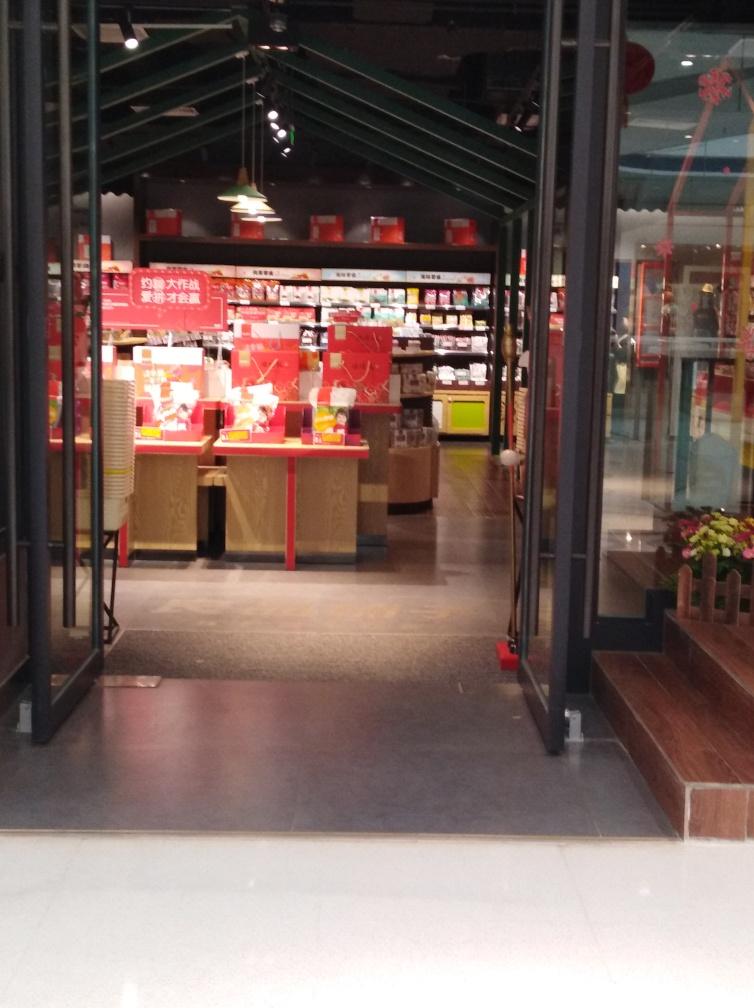What kind of shop is shown in the image? The image shows an interior view of a retail shop that appears to specialize in books, stationery, or similar products. The shelves are well-stocked with neatly arranged items, suggesting a well-organized and possibly a high-quality store. Prominently displayed red signs suggest ongoing promotions or sales. Is there anything that indicates a specific time of year or occasion? Yes, there are decorations resembling paper cutouts on the glass surface to the right that might indicate a festive occasion or season, possibly linked to a cultural event. The red color of the signs and decorations could also suggest a celebration or a holiday theme, traditionally associated with good fortune and joy in some cultures. 